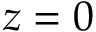<formula> <loc_0><loc_0><loc_500><loc_500>z = 0</formula> 